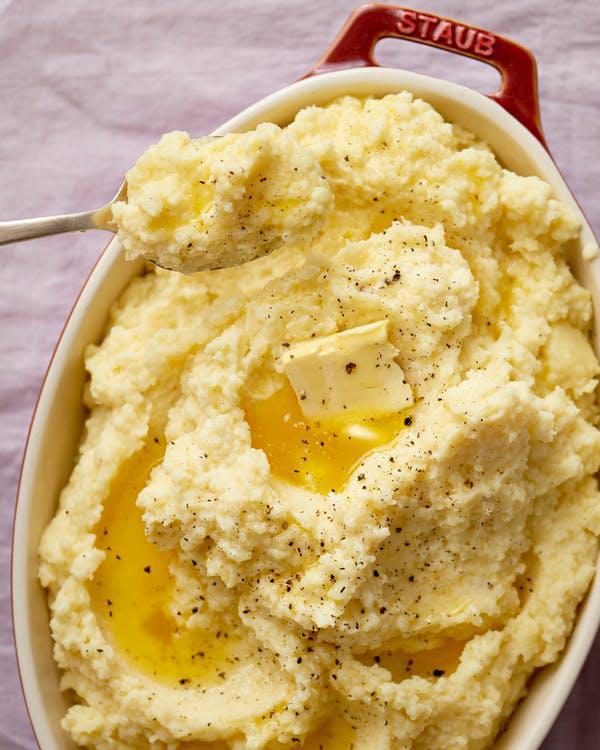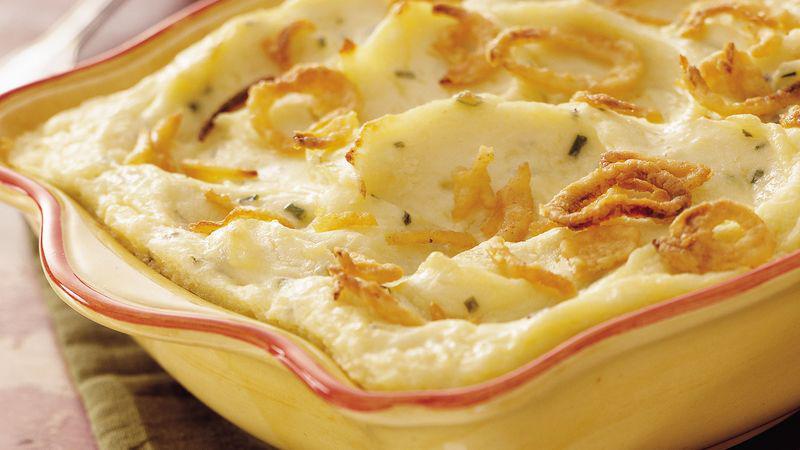The first image is the image on the left, the second image is the image on the right. Given the left and right images, does the statement "The left image shows mashed potatoes in an oblong white bowl with cut-out handles." hold true? Answer yes or no. Yes. The first image is the image on the left, the second image is the image on the right. Considering the images on both sides, is "The left and right image contains two round bowls with mash potatoes." valid? Answer yes or no. No. 